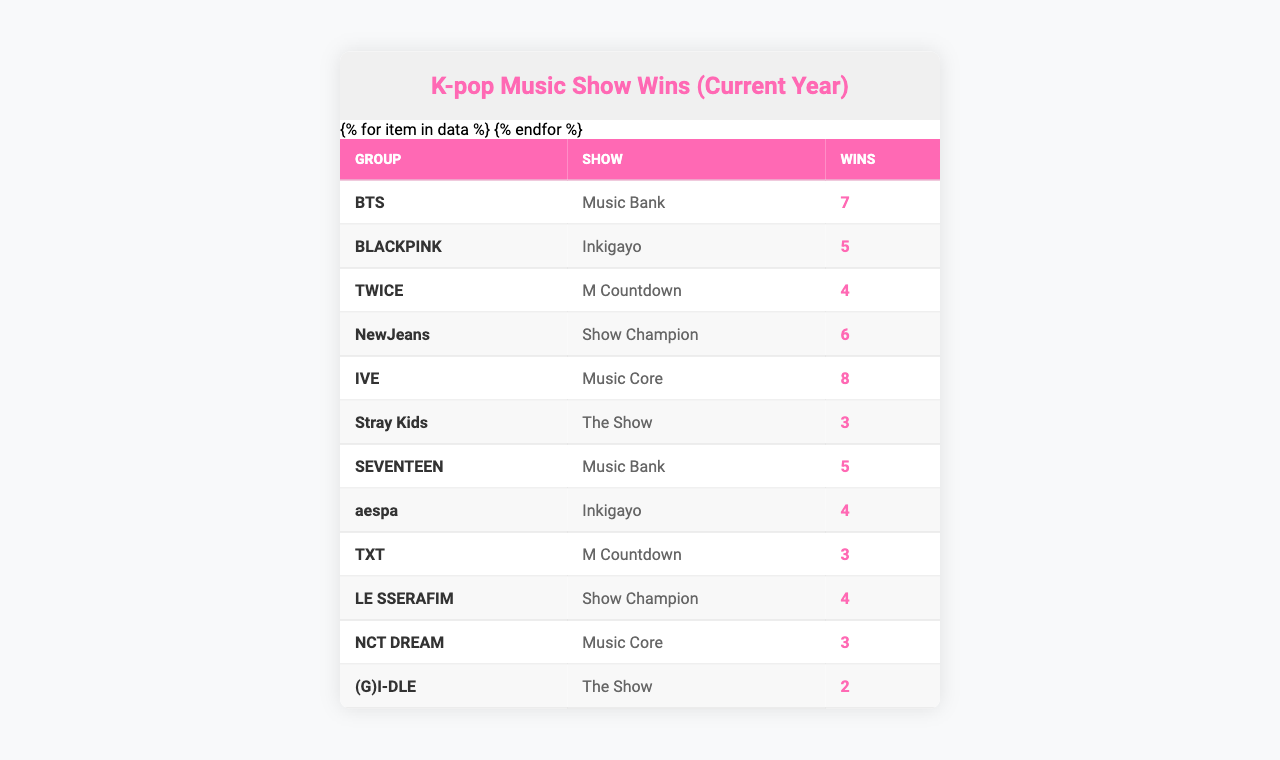What group has the most music show wins? By looking at the table, I can see that IVE has 8 wins, which is the highest number compared to other groups.
Answer: IVE How many wins did BLACKPINK achieve? The table indicates that BLACKPINK has 5 wins as shown in the entries.
Answer: 5 Which group participated in Music Core? Three groups participated in Music Core: IVE (8 wins), NCT DREAM (3 wins), and SEVENTEEN (5 wins).
Answer: IVE, NCT DREAM, SEVENTEEN What is the total number of wins for groups in the "The Show"? Adding the wins for (G)I-DLE (2 wins), Stray Kids (3 wins), and the total is 2 + 3 = 5 wins.
Answer: 5 Is it true that TWICE has more wins than Stray Kids? TWICE has 4 wins while Stray Kids has 3 wins, so TWICE does indeed have more wins than Stray Kids.
Answer: Yes How many more wins does BTS have compared to Stray Kids? BTS has 7 wins, and Stray Kids has 3 wins, so the difference is 7 - 3 = 4 wins.
Answer: 4 What is the median number of wins among all the groups? The total wins from all groups are: 7, 5, 4, 6, 8, 3, 5, 4, 3, 4, 3, 2. Arranging these: 2, 3, 3, 3, 4, 4, 4, 5, 5, 6, 7, 8. The median values (4 and 4) averaged gives (4 + 4)/2 = 4.
Answer: 4 How many groups won exactly 3 times? The table shows that there are three groups with exactly 3 wins: Stray Kids, TXT, and NCT DREAM.
Answer: 3 Which show had the highest combined wins from all groups listed? Music Bank had the highest combined wins with BTS (7) and SEVENTEEN (5), adding to a total of 12 wins.
Answer: Music Bank Which group has participated in more than one show? Looking at the data in the table, each group seems to be listed with their unique participation; thus, no group has participated in more than one show indicated.
Answer: No group has participated in more than one show 